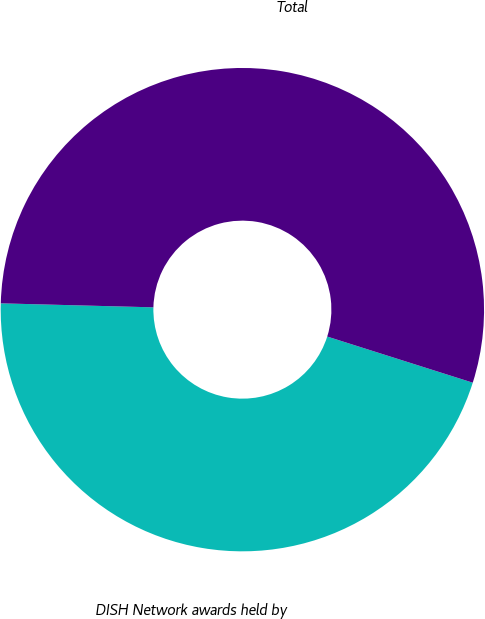Convert chart to OTSL. <chart><loc_0><loc_0><loc_500><loc_500><pie_chart><fcel>DISH Network awards held by<fcel>Total<nl><fcel>45.53%<fcel>54.47%<nl></chart> 